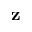Convert formula to latex. <formula><loc_0><loc_0><loc_500><loc_500>z</formula> 